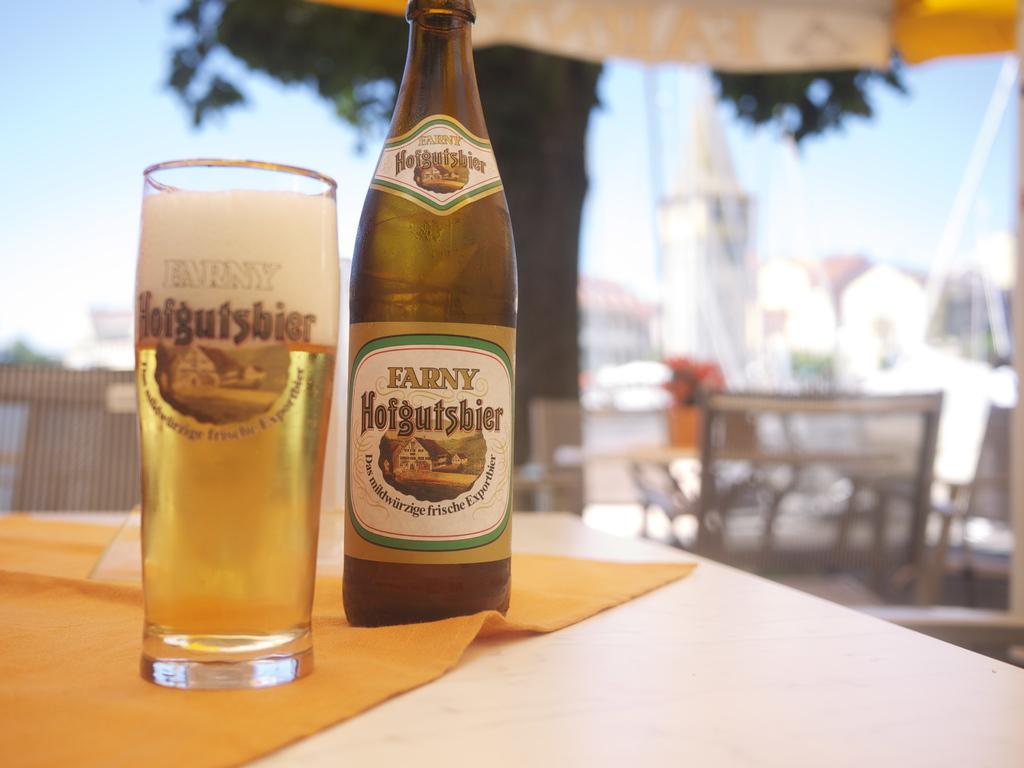Can you describe this image briefly? In the picture we can find a table. On the table we can find wine bottle and a glass with wine. In the background we can find some chairs, tree, sky and buildings. And the wine bottle placed on a cloth. 